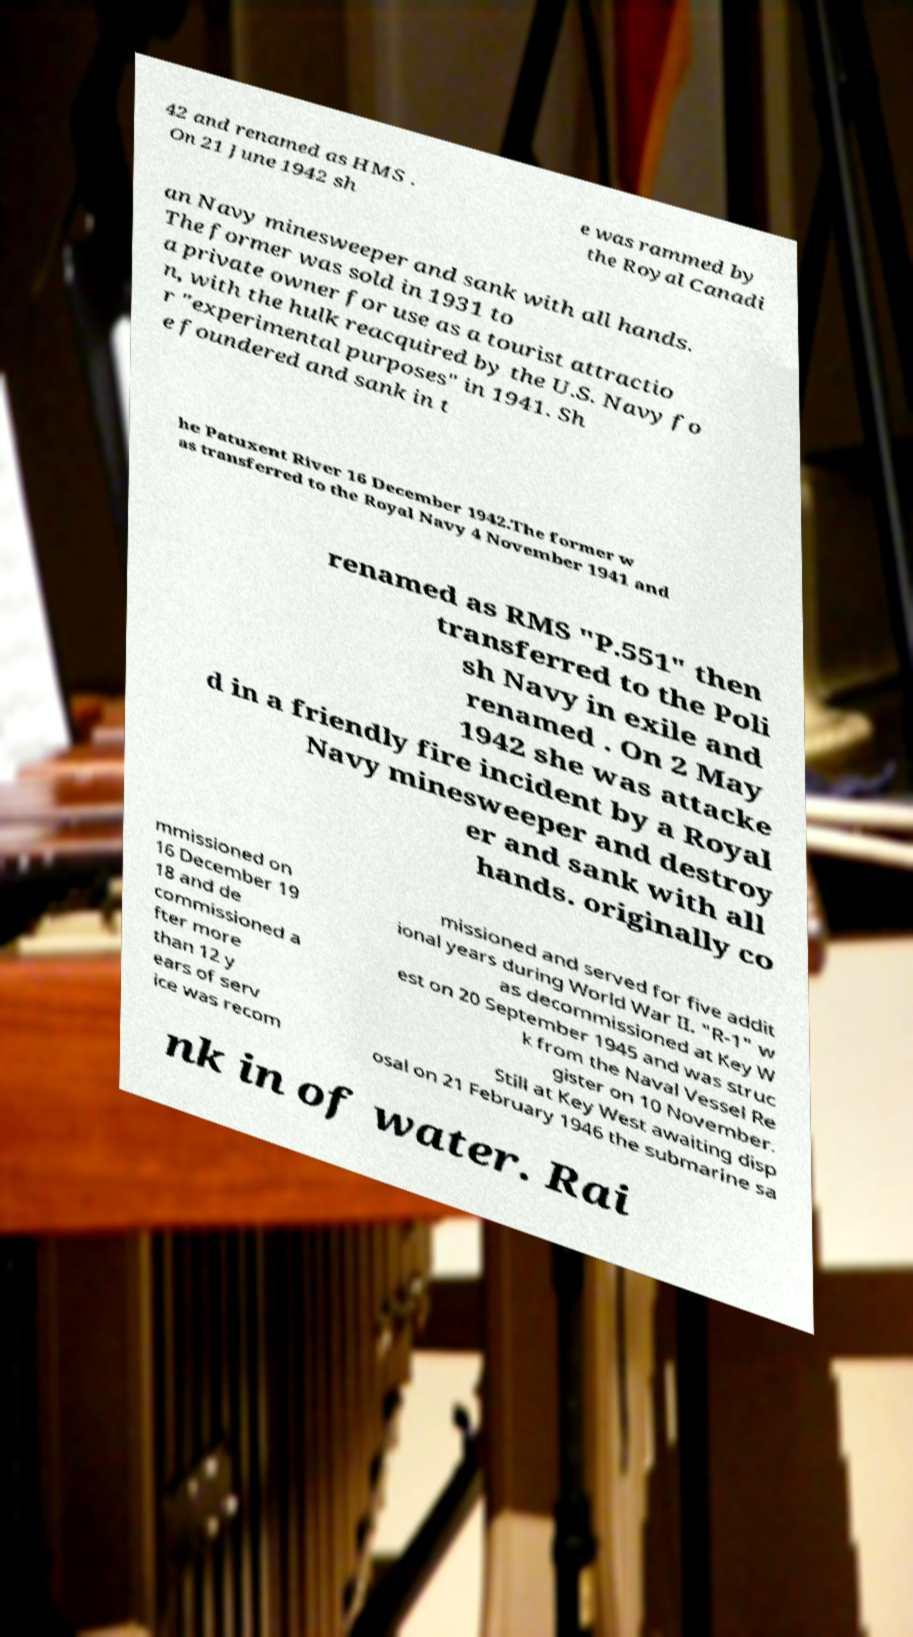There's text embedded in this image that I need extracted. Can you transcribe it verbatim? 42 and renamed as HMS . On 21 June 1942 sh e was rammed by the Royal Canadi an Navy minesweeper and sank with all hands. The former was sold in 1931 to a private owner for use as a tourist attractio n, with the hulk reacquired by the U.S. Navy fo r "experimental purposes" in 1941. Sh e foundered and sank in t he Patuxent River 16 December 1942.The former w as transferred to the Royal Navy 4 November 1941 and renamed as RMS "P.551" then transferred to the Poli sh Navy in exile and renamed . On 2 May 1942 she was attacke d in a friendly fire incident by a Royal Navy minesweeper and destroy er and sank with all hands. originally co mmissioned on 16 December 19 18 and de commissioned a fter more than 12 y ears of serv ice was recom missioned and served for five addit ional years during World War II. "R-1" w as decommissioned at Key W est on 20 September 1945 and was struc k from the Naval Vessel Re gister on 10 November. Still at Key West awaiting disp osal on 21 February 1946 the submarine sa nk in of water. Rai 